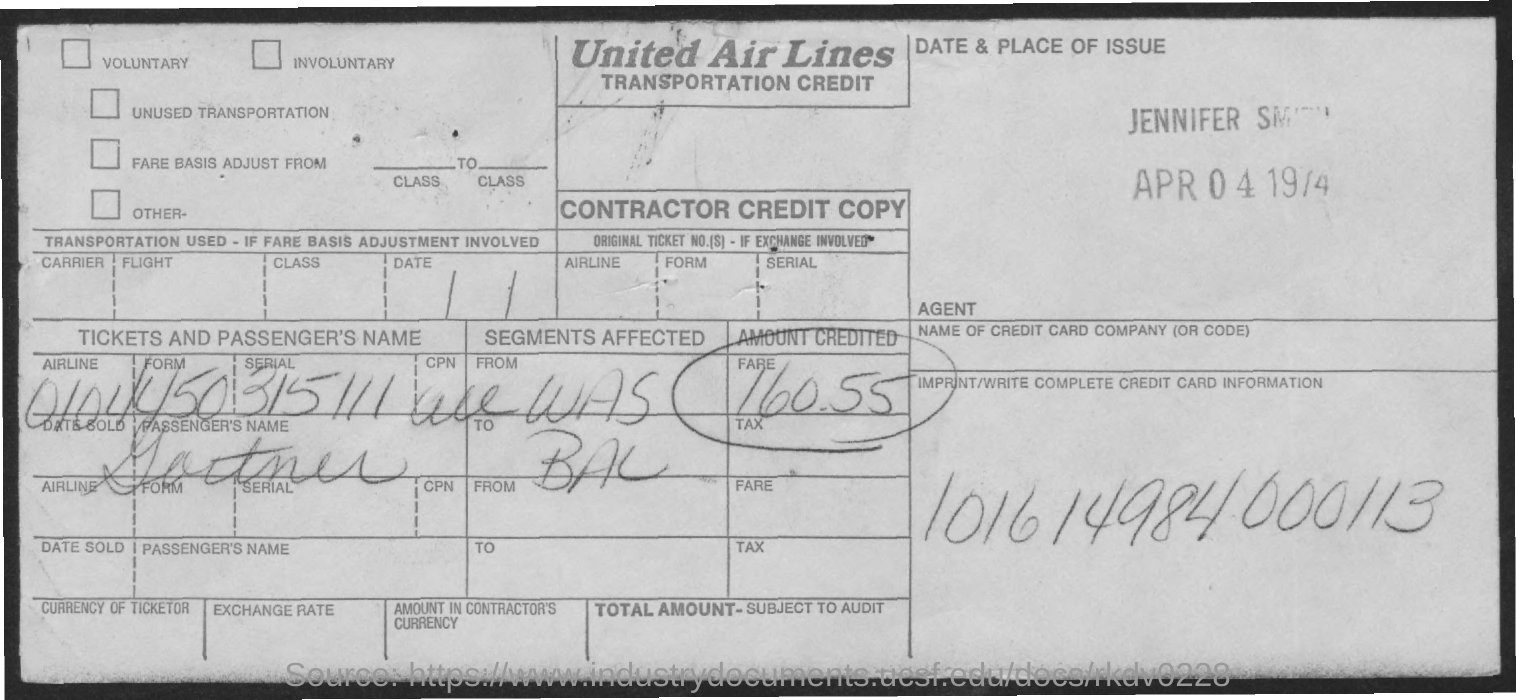Mention a couple of crucial points in this snapshot. The credit card information provided in the form is 101614984000113. The United Air Lines are mentioned in the form. The amount credited in the form is 160.55...," the user declared. 